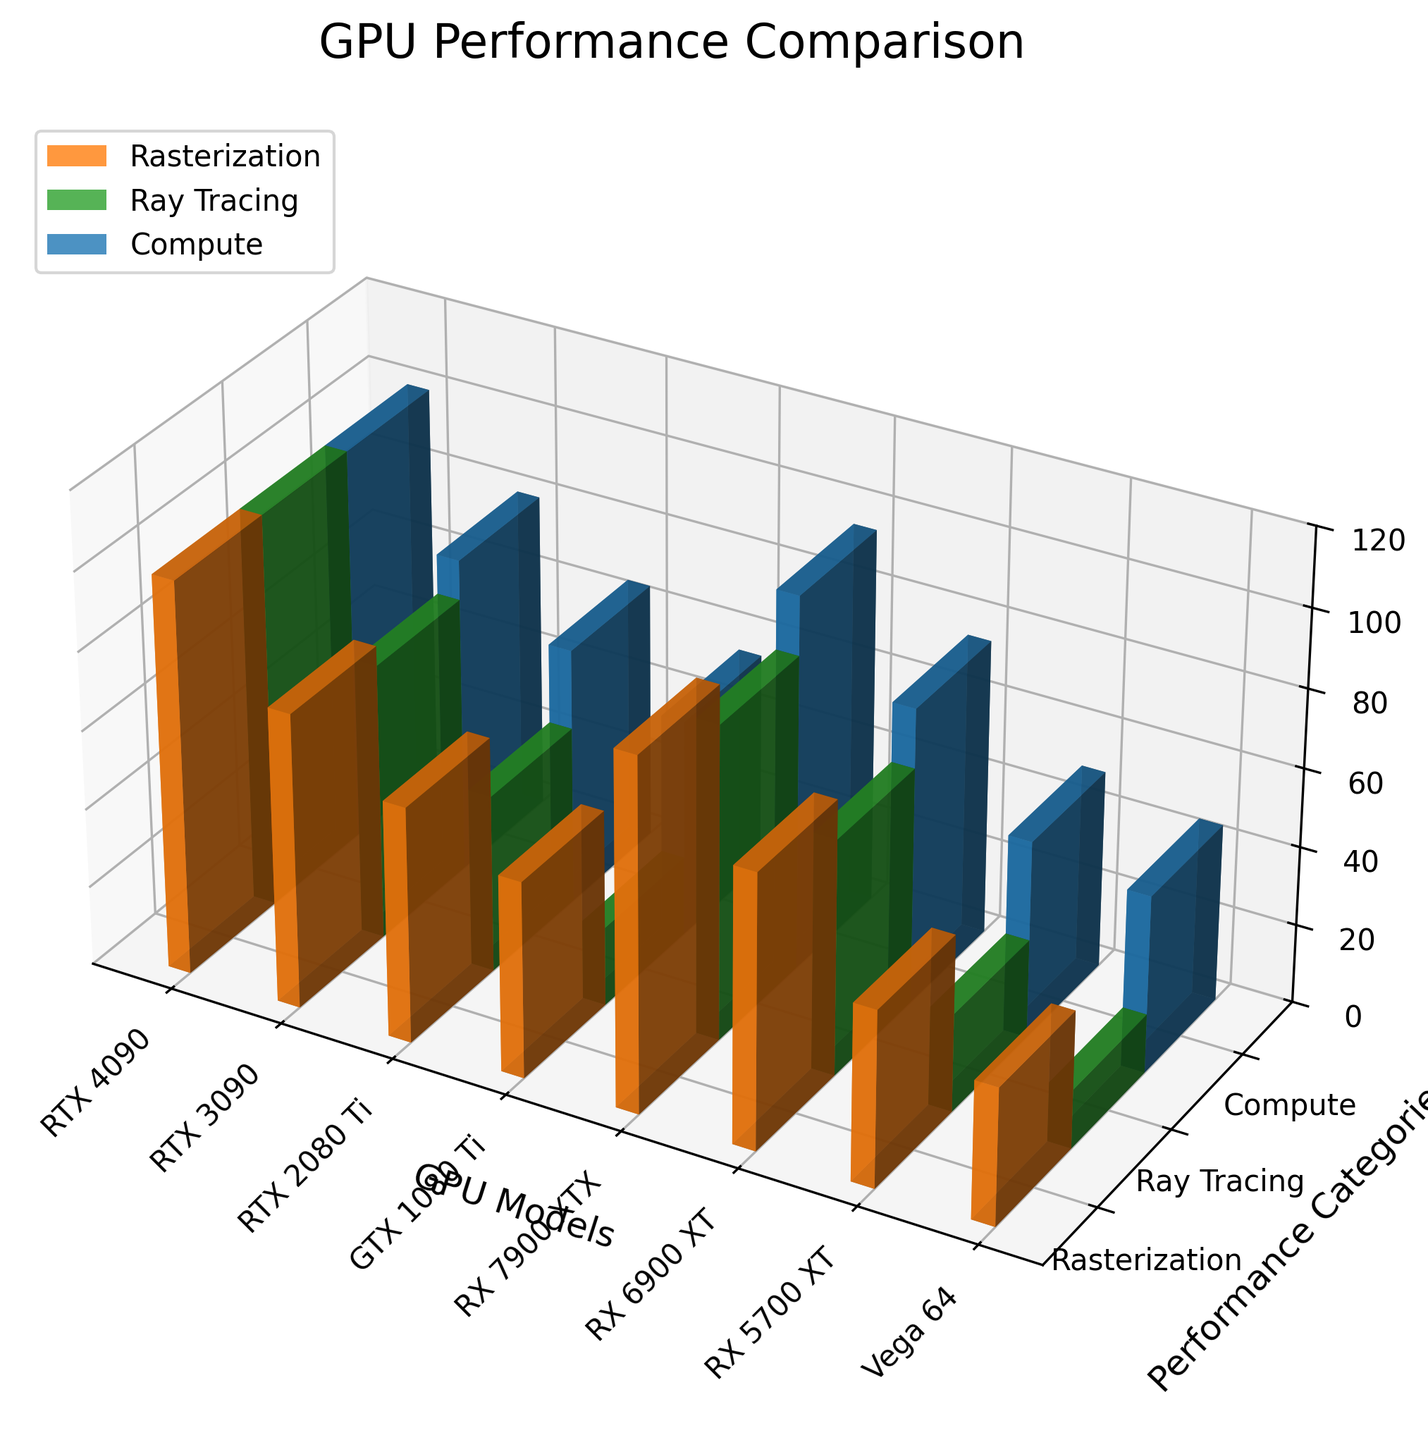what are the three performance categories displayed in the plot? The y-axis of the plot is labeled as "Performance Categories" and shows three distinct labels. These labels represent the three different performance categories measured for the GPUs.
Answer: Rasterization, Ray Tracing, Compute what GPU model shows the highest performance in Ray Tracing? By examining the bars representing Ray Tracing tasks (middle position at each x-tick), the tallest bar, which corresponds to the GPU model, indicates the highest performance. The tallest bar for Ray Tracing is for the RTX 4090.
Answer: RTX 4090 how many different GPU models are compared in the plot? The x-axis of the plot lists the different GPU models, and by counting the unique labels on this axis, we can determine the number of different GPU models shown. There are eight different labels.
Answer: 8 do Ada Lovelace and Ampere generations have a difference in Compute performance? First, locate the bars corresponding to the Ada Lovelace and Ampere generations. Compare their heights within the Compute category (rightmost bars of each group). The Compute performance difference is found by subtracting the Ampere value (80) from the Ada Lovelace value (100).
Answer: 20 Which generation has the lowest performance in Ray Tracing? By examining the bars representing Ray Tracing tasks (middle position at each x-tick) for all GPU models, the shortest bar indicates the GPU with the lowest performance. The shortest bar for Ray Tracing belongs to Vega 64.
Answer: GCN 5 what is the average performance of the RX 5700 XT across all three categories? To find the average, add up the performance scores for all three categories for RX 5700 XT and then divide by the number of categories: (45 + 25 + 50) / 3 = 120 / 3.
Answer: 40 which GPU has a higher combined score in Rasterization and Compute: RTX 2080 Ti or RX 5700 XT? Calculate combined scores by adding the Rasterization and Compute scores for each GPU. For RTX 2080 Ti, it's 60 + 65 = 125. For RX 5700 XT, it's 45 + 50 = 95. Compare the two scores to see which is higher.
Answer: RTX 2080 Ti how many performance categories are graphed for each GPU model? By looking at the number of bars in each group corresponding to a GPU model along the x-axis, we see three separate bars indicating that there are three performance categories for each GPU.
Answer: 3 identify the GPU with the closest performance in Rasterization and Compute categories. Compare the heights of the Rasterization and Compute bars for each GPU, looking for the pair with the smallest difference in height. The closest values are from GTX 1080 Ti with Rasterization at 50 and Compute at 55, showing a difference of 5.
Answer: GTX 1080 Ti what is the performance difference in Rasterization between RX 7900 XTX and RX 5700 XT? Determine the heights of the Rasterization bars for RX 7900 XTX and RX 5700 XT and subtract the smaller value from the larger value: 90 - 45.
Answer: 45 